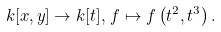Convert formula to latex. <formula><loc_0><loc_0><loc_500><loc_500>k [ x , y ] \to k [ t ] , \, f \mapsto f \left ( t ^ { 2 } , t ^ { 3 } \right ) .</formula> 